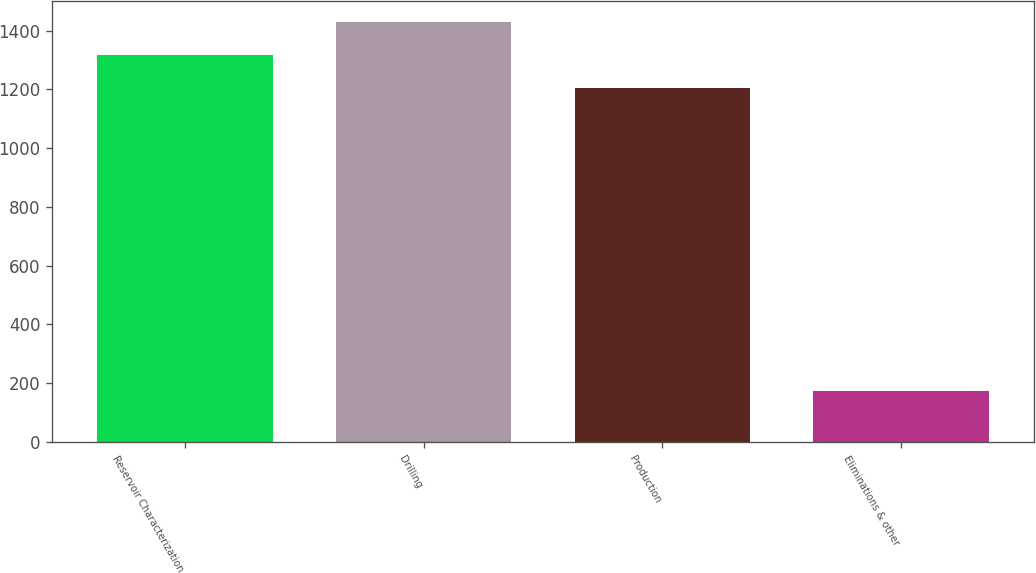Convert chart. <chart><loc_0><loc_0><loc_500><loc_500><bar_chart><fcel>Reservoir Characterization<fcel>Drilling<fcel>Production<fcel>Eliminations & other<nl><fcel>1315.8<fcel>1427.6<fcel>1204<fcel>173<nl></chart> 